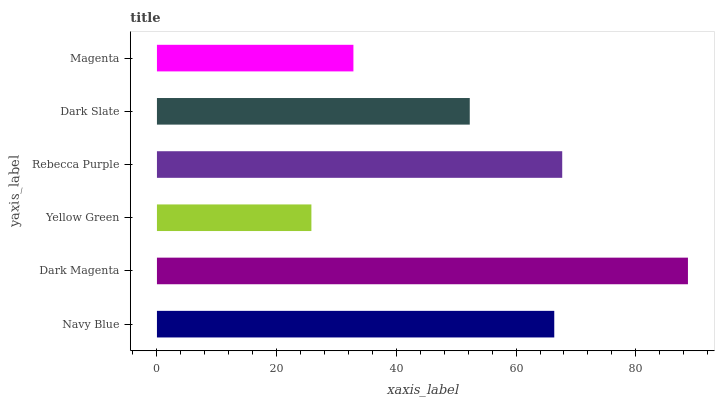Is Yellow Green the minimum?
Answer yes or no. Yes. Is Dark Magenta the maximum?
Answer yes or no. Yes. Is Dark Magenta the minimum?
Answer yes or no. No. Is Yellow Green the maximum?
Answer yes or no. No. Is Dark Magenta greater than Yellow Green?
Answer yes or no. Yes. Is Yellow Green less than Dark Magenta?
Answer yes or no. Yes. Is Yellow Green greater than Dark Magenta?
Answer yes or no. No. Is Dark Magenta less than Yellow Green?
Answer yes or no. No. Is Navy Blue the high median?
Answer yes or no. Yes. Is Dark Slate the low median?
Answer yes or no. Yes. Is Dark Magenta the high median?
Answer yes or no. No. Is Navy Blue the low median?
Answer yes or no. No. 